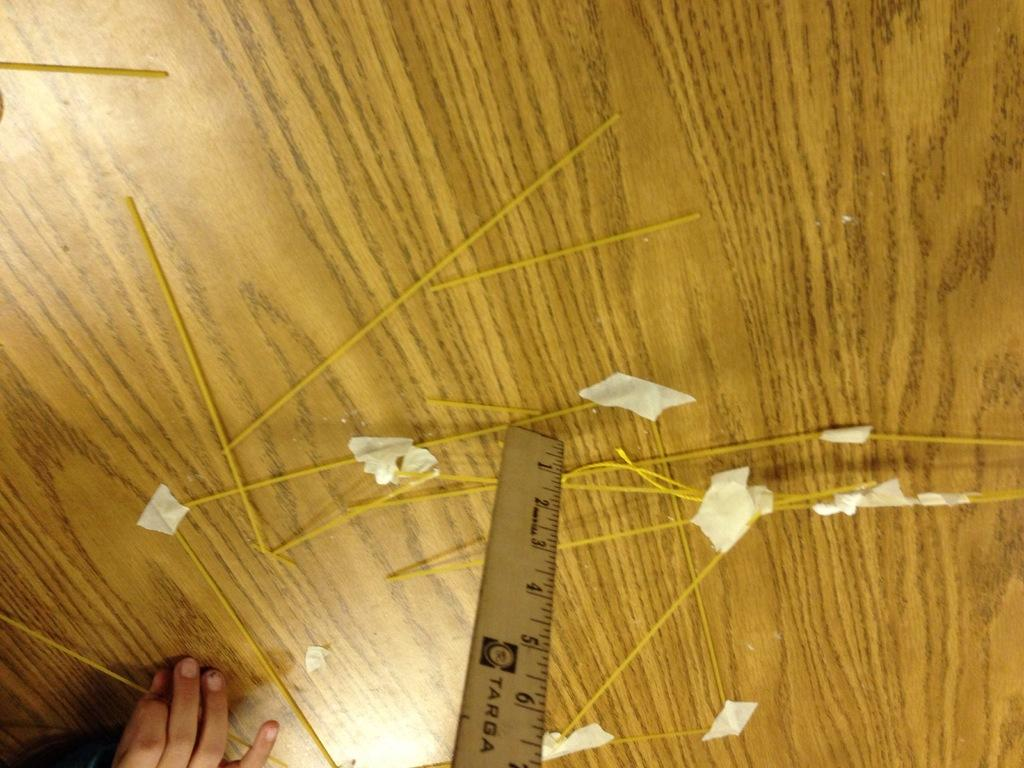<image>
Create a compact narrative representing the image presented. A Targa ruler laying in the middle of spaghetti. 